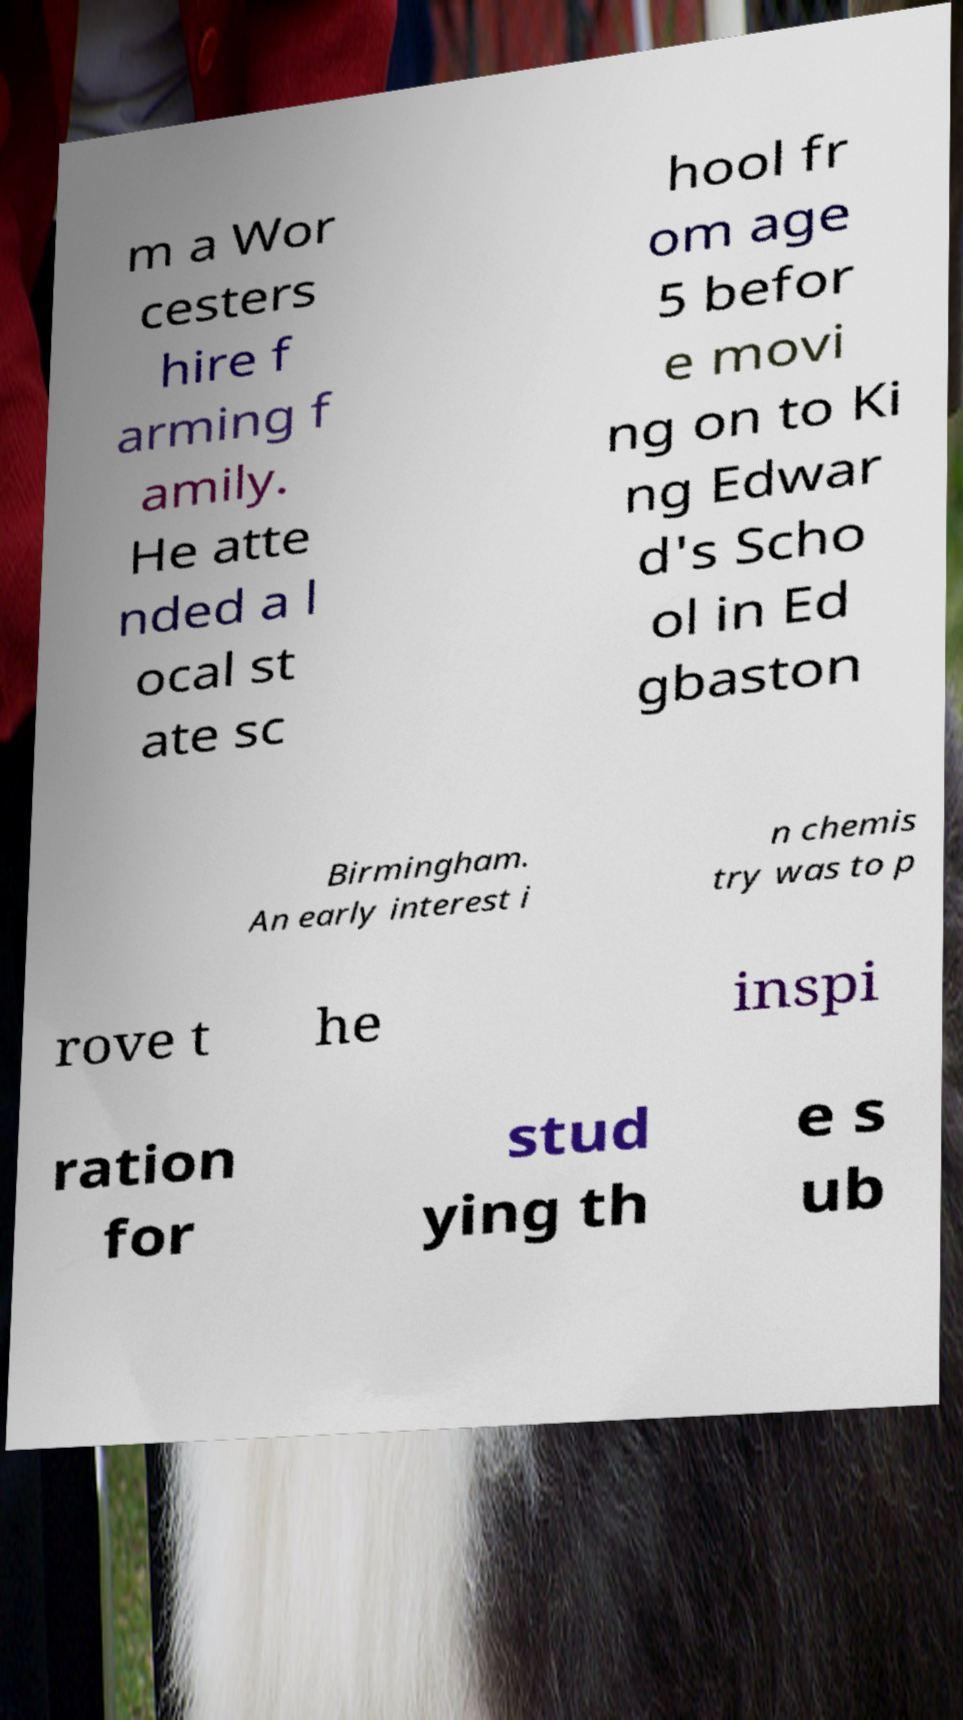There's text embedded in this image that I need extracted. Can you transcribe it verbatim? m a Wor cesters hire f arming f amily. He atte nded a l ocal st ate sc hool fr om age 5 befor e movi ng on to Ki ng Edwar d's Scho ol in Ed gbaston Birmingham. An early interest i n chemis try was to p rove t he inspi ration for stud ying th e s ub 